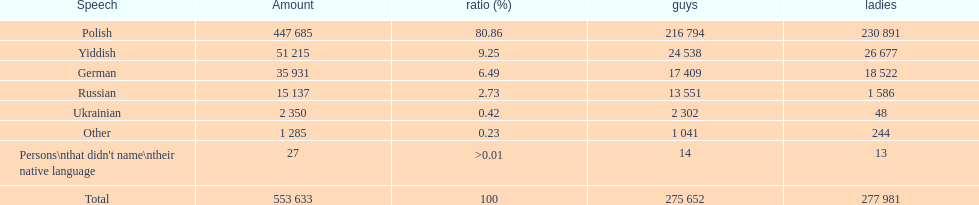How many languages have a name that is derived from a country? 4. Can you parse all the data within this table? {'header': ['Speech', 'Amount', 'ratio (%)', 'guys', 'ladies'], 'rows': [['Polish', '447 685', '80.86', '216 794', '230 891'], ['Yiddish', '51 215', '9.25', '24 538', '26 677'], ['German', '35 931', '6.49', '17 409', '18 522'], ['Russian', '15 137', '2.73', '13 551', '1 586'], ['Ukrainian', '2 350', '0.42', '2 302', '48'], ['Other', '1 285', '0.23', '1 041', '244'], ["Persons\\nthat didn't name\\ntheir native language", '27', '>0.01', '14', '13'], ['Total', '553 633', '100', '275 652', '277 981']]} 